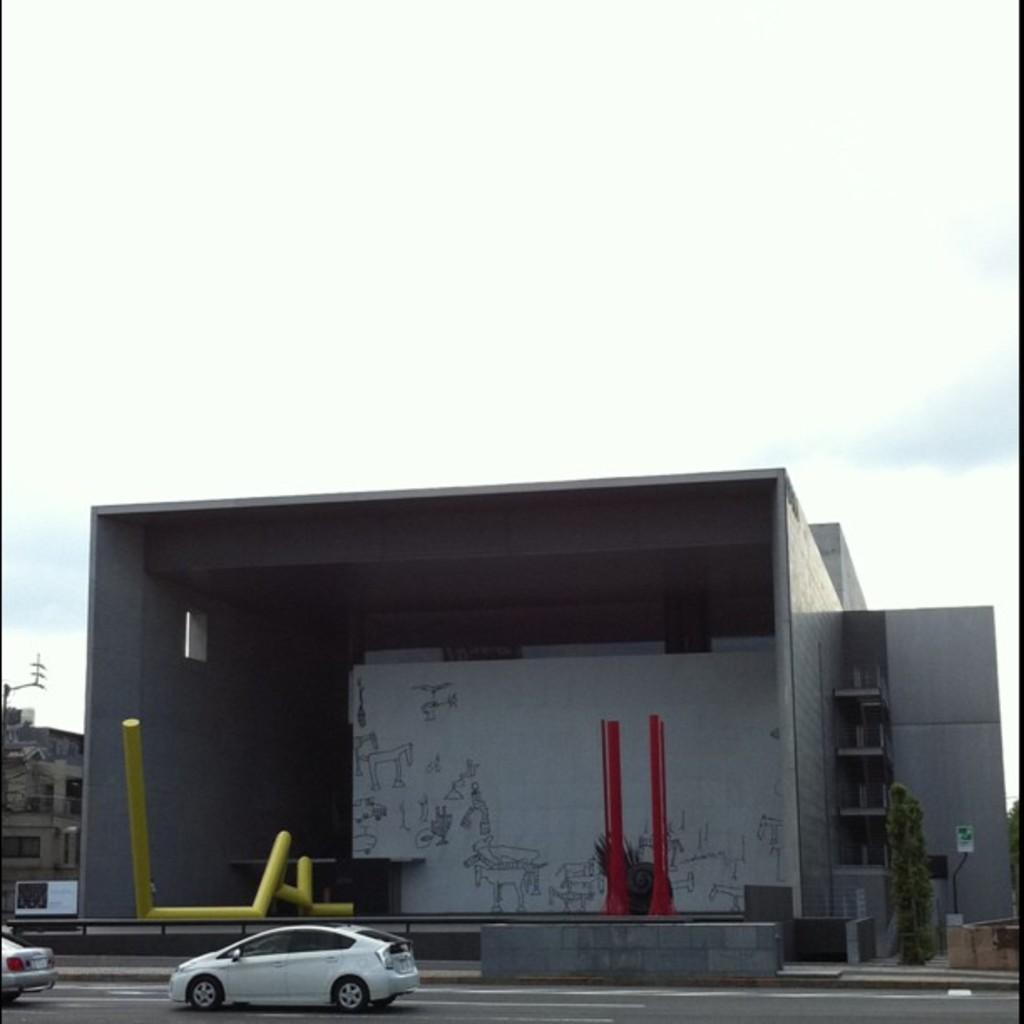In one or two sentences, can you explain what this image depicts? In the center of the image, we can see a building and here we can see a board with some text and there are stands, tables, trees, railings and there is an other building. At the bottom, there are vehicles on the road. At the top, there is sky. 